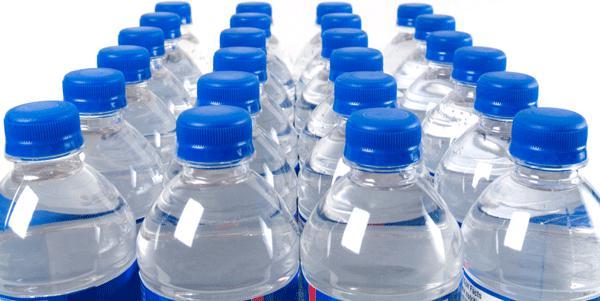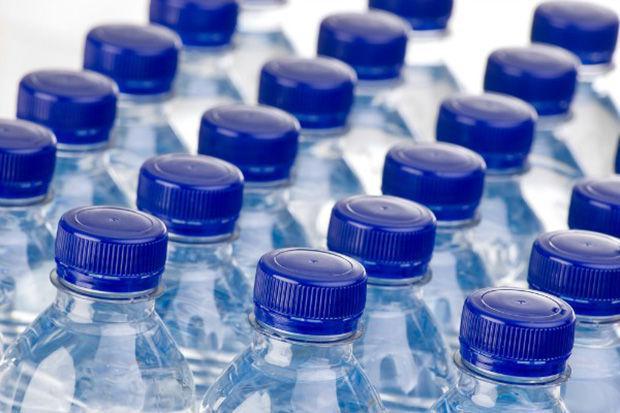The first image is the image on the left, the second image is the image on the right. Considering the images on both sides, is "There are three bottles in one of the images." valid? Answer yes or no. No. 